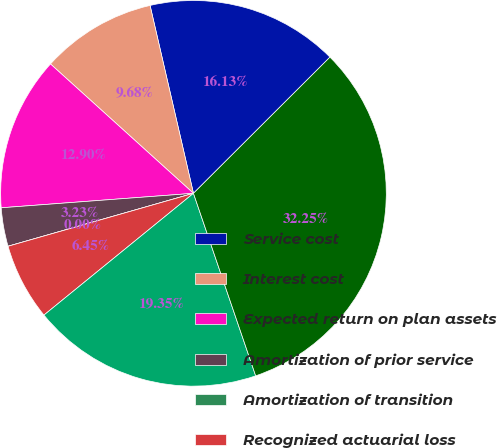Convert chart to OTSL. <chart><loc_0><loc_0><loc_500><loc_500><pie_chart><fcel>Service cost<fcel>Interest cost<fcel>Expected return on plan assets<fcel>Amortization of prior service<fcel>Amortization of transition<fcel>Recognized actuarial loss<fcel>Subtotal<fcel>Net periodic pension cost<nl><fcel>16.13%<fcel>9.68%<fcel>12.9%<fcel>3.23%<fcel>0.0%<fcel>6.45%<fcel>19.35%<fcel>32.25%<nl></chart> 